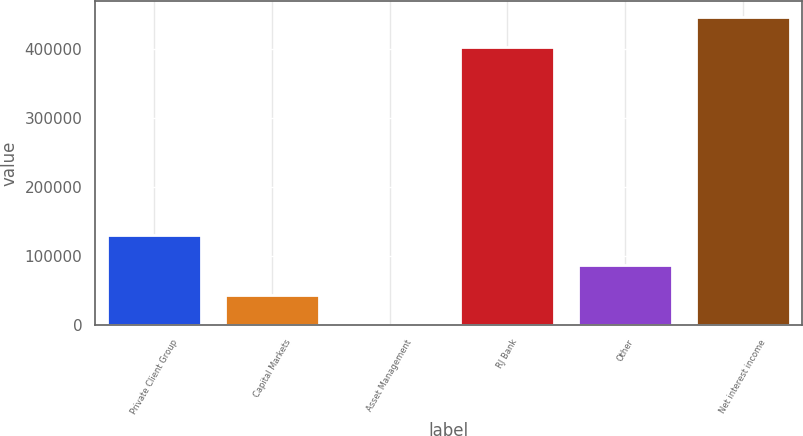Convert chart to OTSL. <chart><loc_0><loc_0><loc_500><loc_500><bar_chart><fcel>Private Client Group<fcel>Capital Markets<fcel>Asset Management<fcel>RJ Bank<fcel>Other<fcel>Net interest income<nl><fcel>130665<fcel>43639.6<fcel>127<fcel>403578<fcel>87152.2<fcel>447091<nl></chart> 